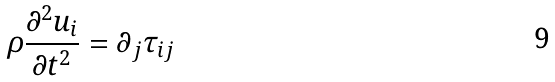Convert formula to latex. <formula><loc_0><loc_0><loc_500><loc_500>\rho \frac { \partial ^ { 2 } u _ { i } } { \partial t ^ { 2 } } = \partial _ { j } \tau _ { i j }</formula> 